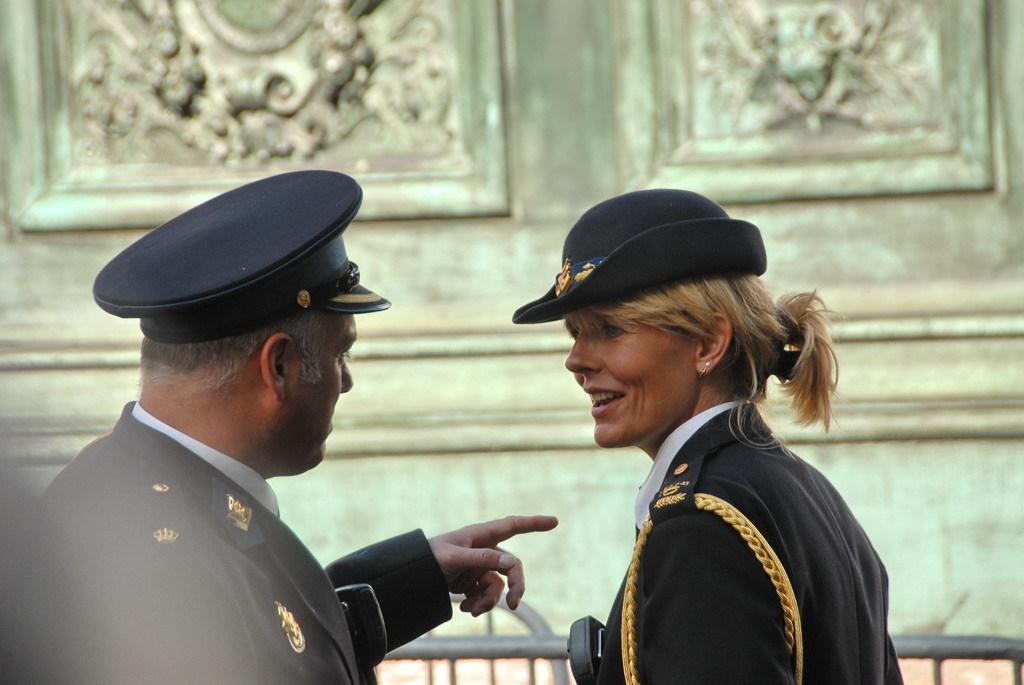Can you describe this image briefly? In the center of the image we can see two persons are standing and wearing a uniform and cap. In the background of the image we can see the wall. At the bottom of the image we can see the rods and floor. 